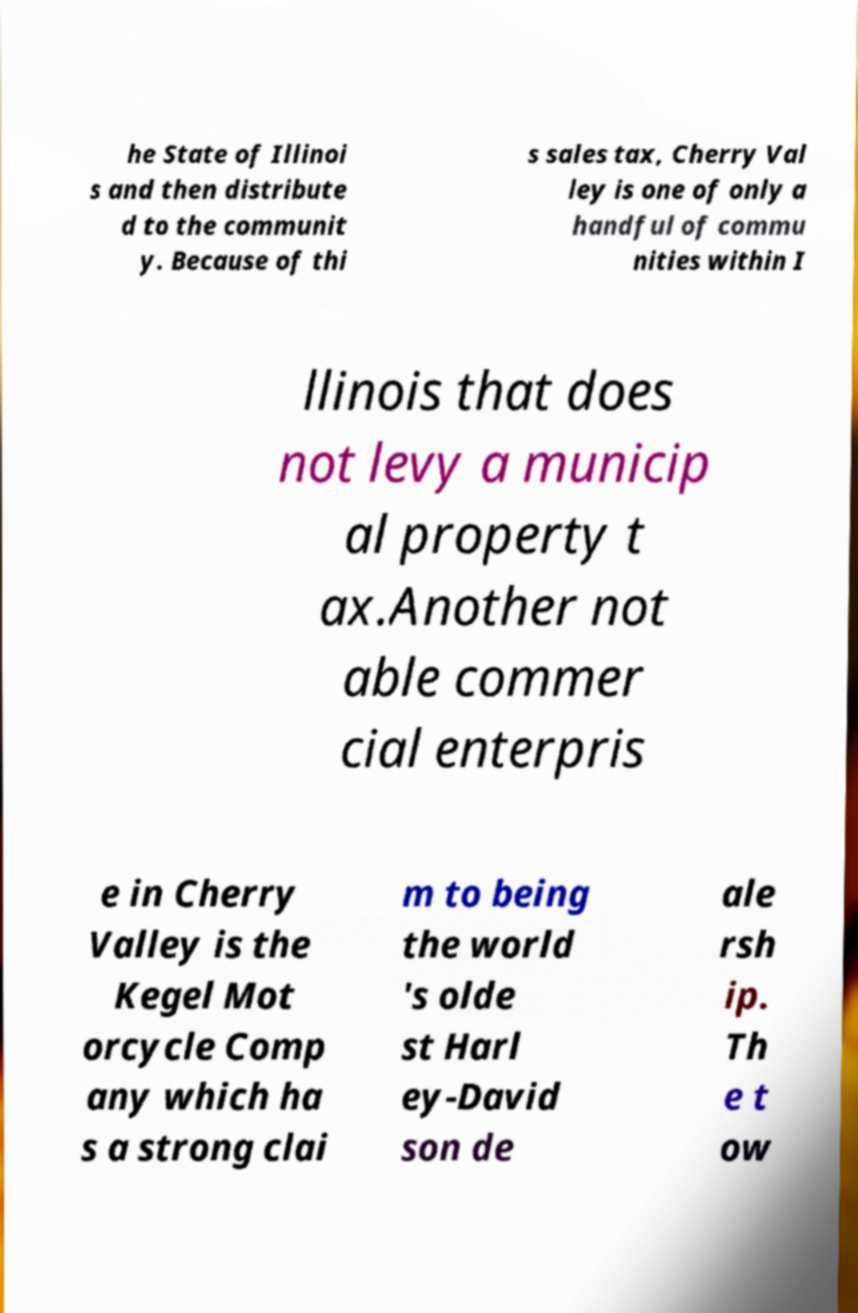What messages or text are displayed in this image? I need them in a readable, typed format. he State of Illinoi s and then distribute d to the communit y. Because of thi s sales tax, Cherry Val ley is one of only a handful of commu nities within I llinois that does not levy a municip al property t ax.Another not able commer cial enterpris e in Cherry Valley is the Kegel Mot orcycle Comp any which ha s a strong clai m to being the world 's olde st Harl ey-David son de ale rsh ip. Th e t ow 